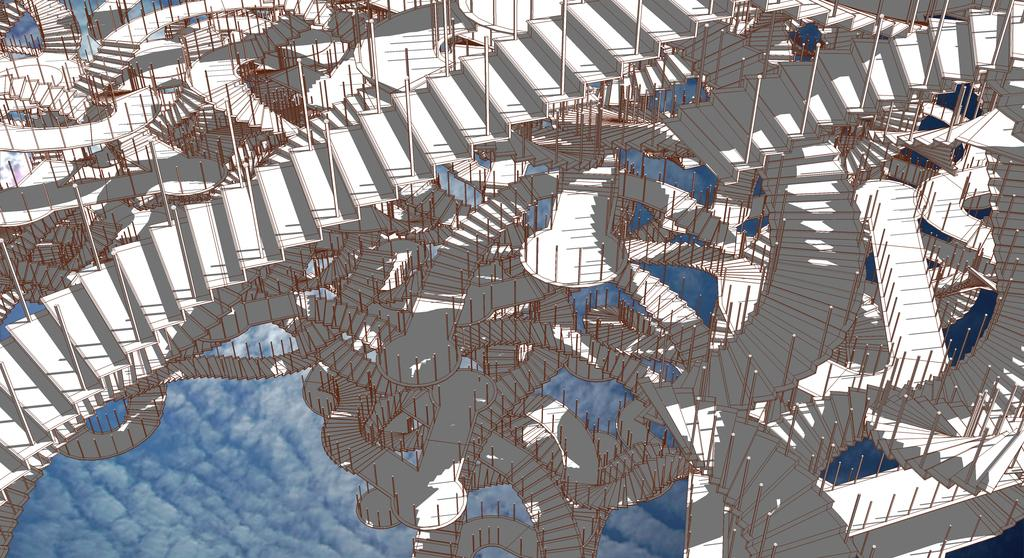What is the main subject of the image? The main subject of the image is a graphic design of staircases. What can be seen in the background of the image? The sky is visible in the image. What is present in the sky? Clouds are present in the sky. What type of lettuce can be seen growing on the staircases in the image? There is no lettuce present in the image, as it features a graphic design of staircases with no vegetation. 